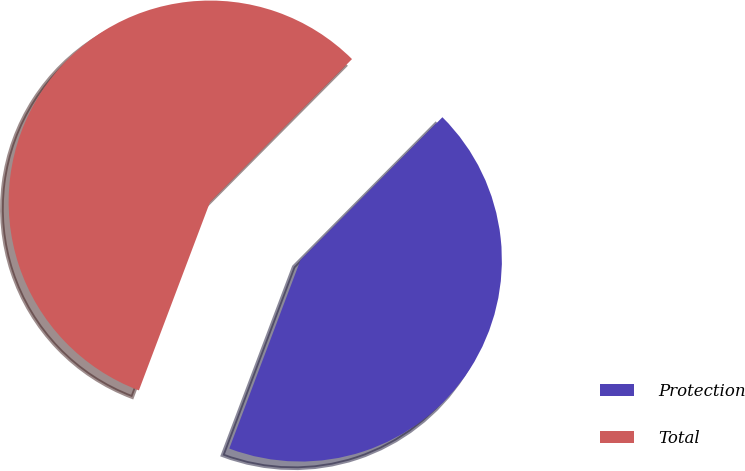Convert chart. <chart><loc_0><loc_0><loc_500><loc_500><pie_chart><fcel>Protection<fcel>Total<nl><fcel>43.3%<fcel>56.7%<nl></chart> 